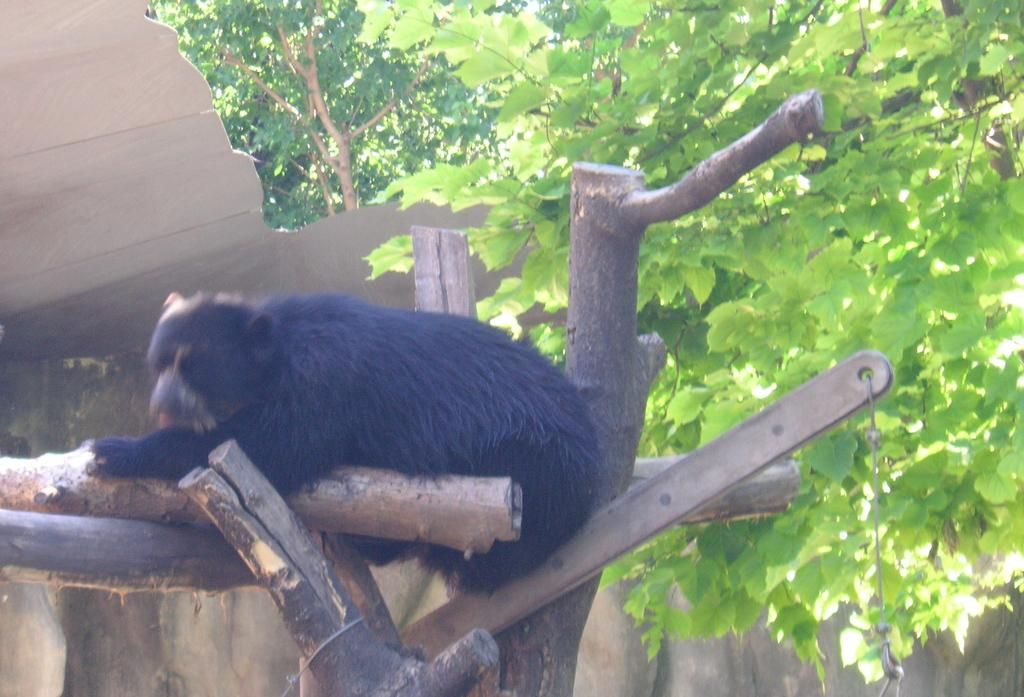What type of animal is in the image? There is a black bear in the image. What can be seen in the background of the image? There are many trees in the image. What type of ship can be seen sailing in the image? There is no ship present in the image; it features a black bear and trees. How many bottles are visible in the image? There are no bottles present in the image. 